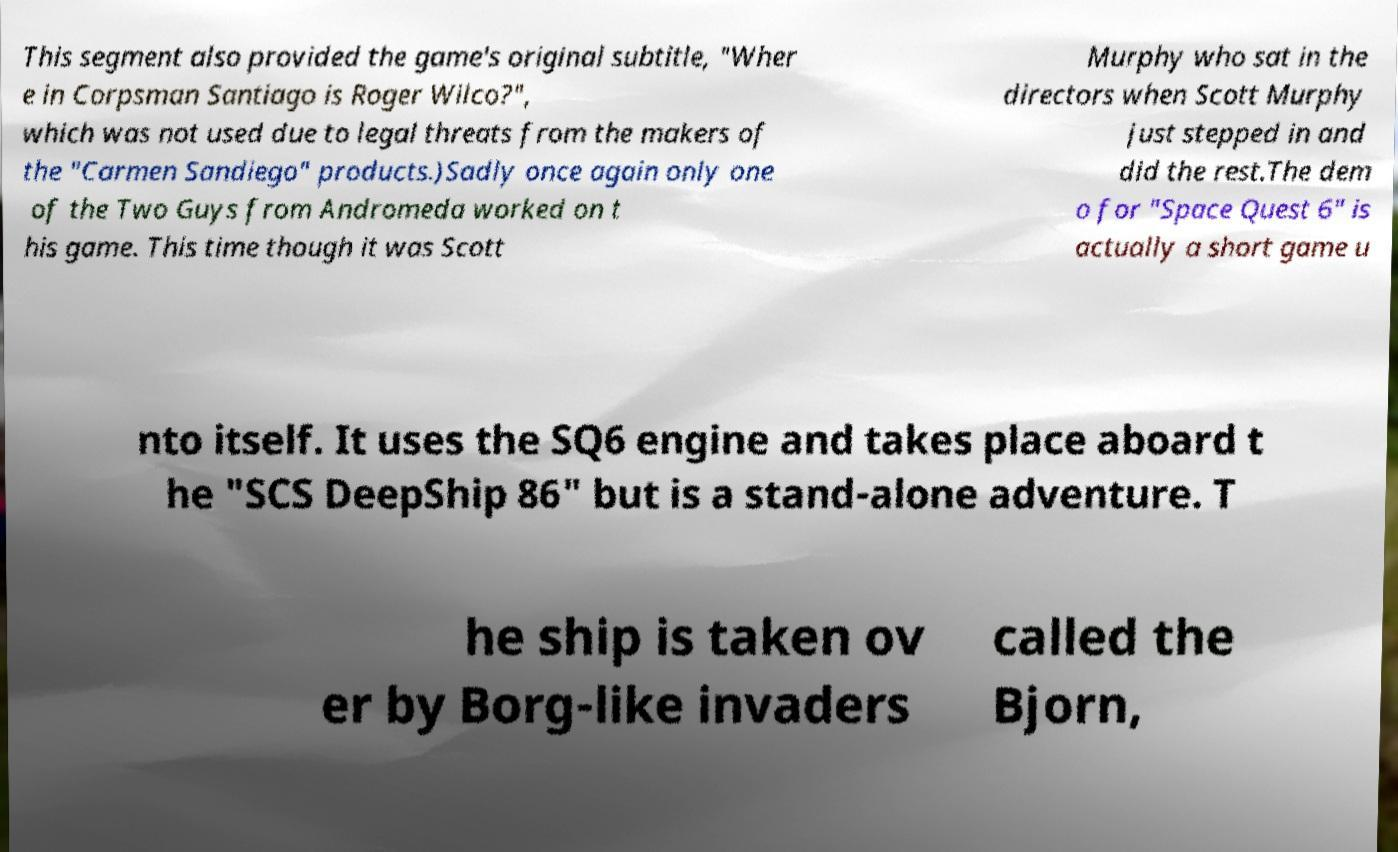Please read and relay the text visible in this image. What does it say? This segment also provided the game's original subtitle, "Wher e in Corpsman Santiago is Roger Wilco?", which was not used due to legal threats from the makers of the "Carmen Sandiego" products.)Sadly once again only one of the Two Guys from Andromeda worked on t his game. This time though it was Scott Murphy who sat in the directors when Scott Murphy just stepped in and did the rest.The dem o for "Space Quest 6" is actually a short game u nto itself. It uses the SQ6 engine and takes place aboard t he "SCS DeepShip 86" but is a stand-alone adventure. T he ship is taken ov er by Borg-like invaders called the Bjorn, 